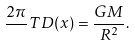<formula> <loc_0><loc_0><loc_500><loc_500>\frac { 2 \pi } { } T D ( x ) = \frac { G M } { R ^ { 2 } } .</formula> 